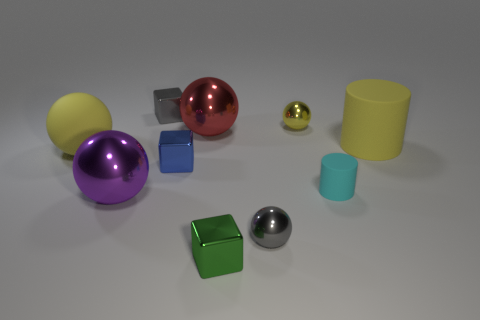How many yellow rubber spheres are behind the yellow matte thing that is on the right side of the tiny green thing that is in front of the blue metallic block?
Ensure brevity in your answer.  0. There is a gray object in front of the small rubber cylinder; what is its size?
Offer a terse response. Small. Is the shape of the matte object left of the green object the same as  the green thing?
Offer a very short reply. No. What is the material of the big yellow object that is the same shape as the small cyan object?
Give a very brief answer. Rubber. Is there any other thing that is the same size as the green object?
Keep it short and to the point. Yes. Is there a red sphere?
Keep it short and to the point. Yes. There is a cylinder left of the yellow rubber object that is on the right side of the small gray metallic thing left of the small green shiny block; what is its material?
Ensure brevity in your answer.  Rubber. There is a red object; is its shape the same as the matte thing that is on the left side of the tiny cylinder?
Keep it short and to the point. Yes. What number of blue shiny things have the same shape as the green shiny object?
Give a very brief answer. 1. What is the shape of the small yellow thing?
Your answer should be compact. Sphere. 